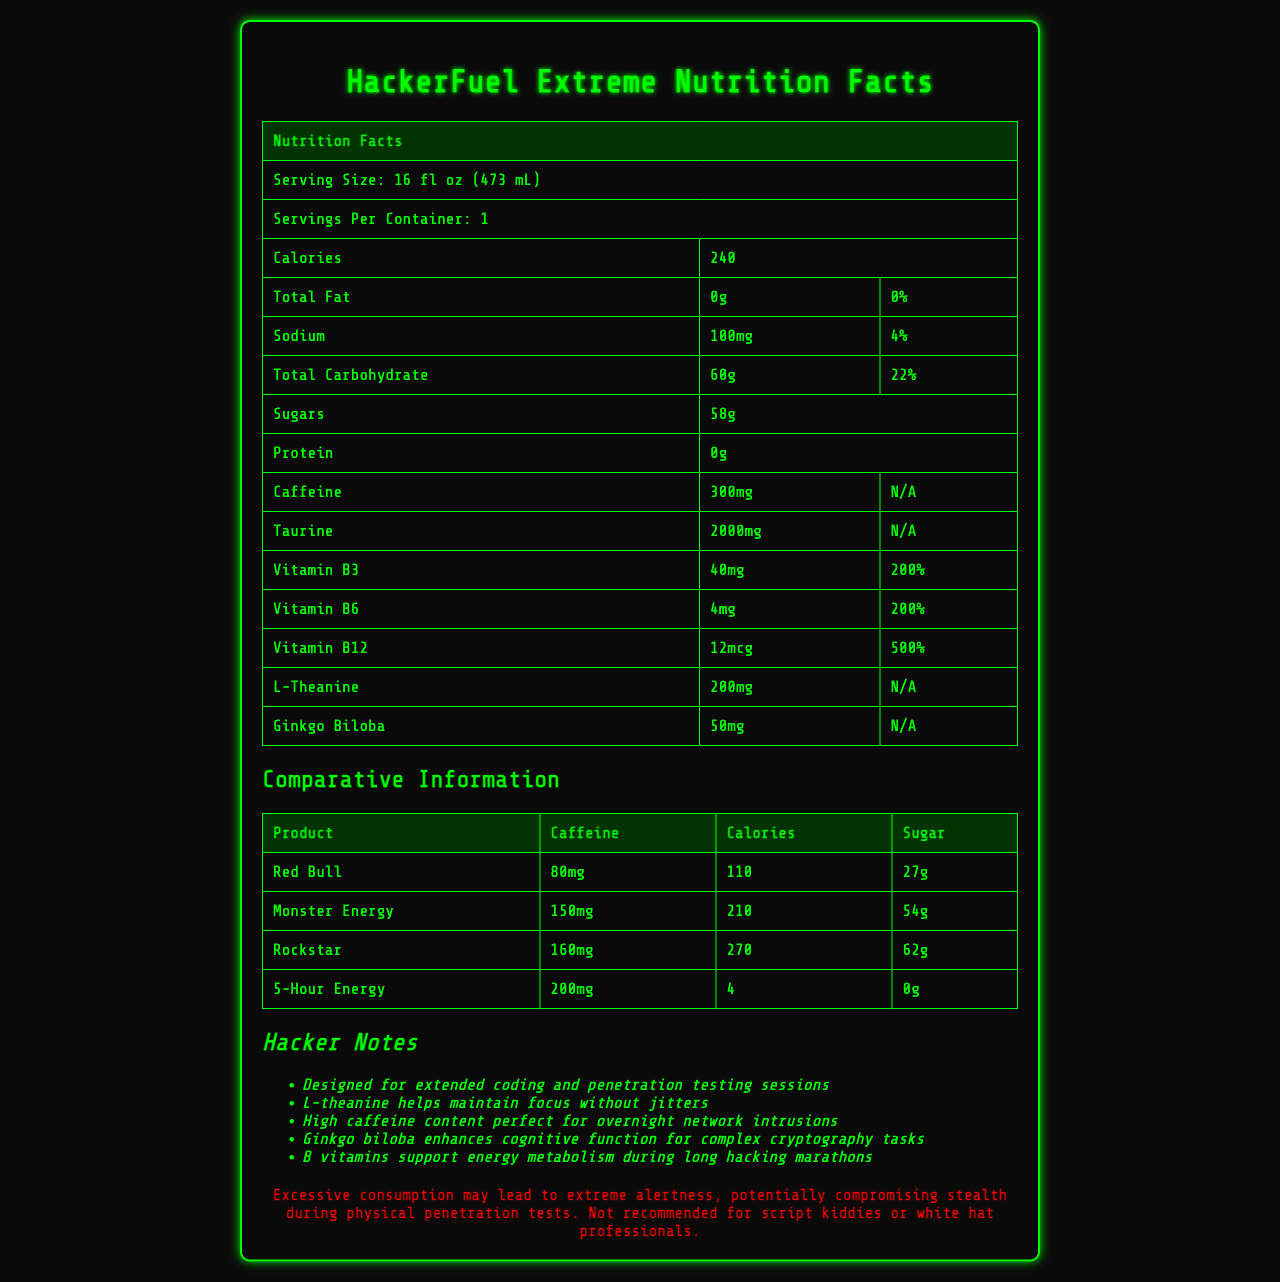what is the serving size of HackerFuel Extreme? The serving size is explicitly listed at the beginning of the nutrition facts section.
Answer: 16 fl oz (473 mL) how many calories are in one serving of HackerFuel Extreme? The calorie content is specified just below the serving size information.
Answer: 240 what percentage of the daily value of vitamin B12 does one serving of HackerFuel Extreme provide? This information is detailed in the section listing vitamins B3, B6, and B12.
Answer: 500% how much caffeine is in a serving of HackerFuel Extreme? The caffeine content is displayed in the nutrition facts section under the caffeine row.
Answer: 300mg how many grams of sugar are in HackerFuel Extreme? The amount of sugars is explicitly mentioned in the nutrition facts section.
Answer: 58g which beverage has the highest sugar content in the comparative information? According to the comparative information table, Rockstar has 62g of sugar, which is the highest among the listed beverages.
Answer: Rockstar which product has the least calories? A. Red Bull B. Monster Energy C. Rockstar D. 5-Hour Energy 5-Hour Energy has only 4 calories, which is significantly lower than the other listed beverages.
Answer: D which vitamin has the highest daily value percentage in HackerFuel Extreme? A. Vitamin B3 B. Vitamin B6 C. Vitamin B12 Vitamin B12 has a daily value of 500%, which is the highest among the listed vitamins.
Answer: C does HackerFuel Extreme contain any fat? The total fat content is listed as "0g," indicating that there is no fat.
Answer: No does HackerFuel Extreme caution against excessive consumption? The warning at the bottom of the document mentions that excessive consumption may lead to extreme alertness and is not recommended for certain individuals.
Answer: Yes what are some additional ingredients in HackerFuel Extreme that aim to enhance cognitive function? According to the hacker notes, these ingredients help maintain focus and enhance cognitive function.
Answer: L-theanine, Ginkgo biloba summarize the main purpose of the HackerFuel Extreme Nutrition Facts document. The document is designed to outline the nutritional and functional benefits of HackerFuel Extreme, particularly for individuals involved in extended coding or penetration testing sessions, while also listing comparative data for other high-caffeine beverages.
Answer: The document provides comprehensive nutritional information for HackerFuel Extreme, including serving size, calorie content, macronutrients, vitamins, and other ingredients. It also compares the product to other high-caffeine beverages and includes special notes and warnings for cybersecurity professionals. what is the main ingredient that supports energy metabolism in HackerFuel Extreme? The hacker notes specifically mention that B vitamins support energy metabolism during long hacking marathons.
Answer: B vitamins which product has the highest caffeine content in the comparative information? The caffeine content for HackerFuel Extreme is listed in the nutrition facts section, but we are comparing only among Red Bull, Monster Energy, Rockstar, and 5-Hour Energy. Among them, HackerFuel Extreme's caffeine content is not directly compared, so we can't determine it from the comparative information alone.
Answer: Cannot be determined 